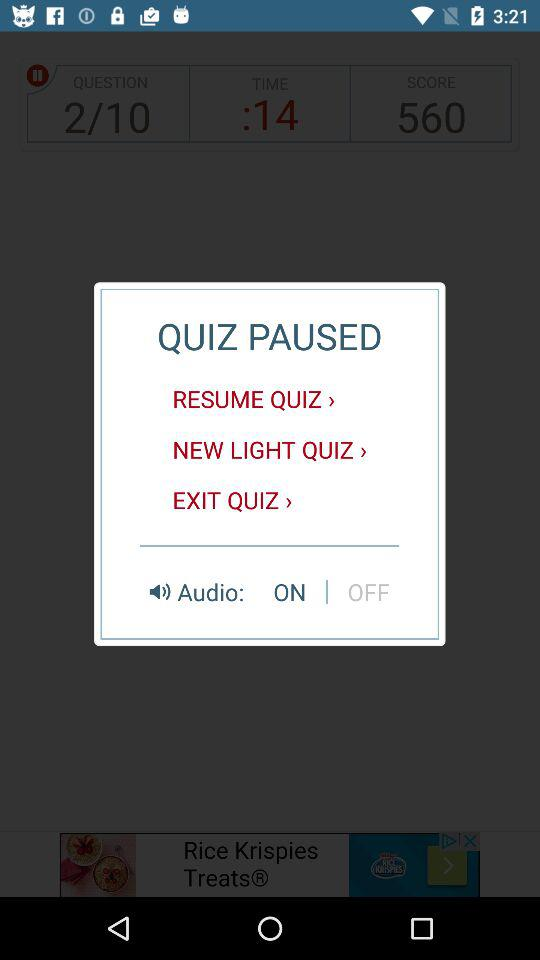How many questions are there? There are 10 questions. 